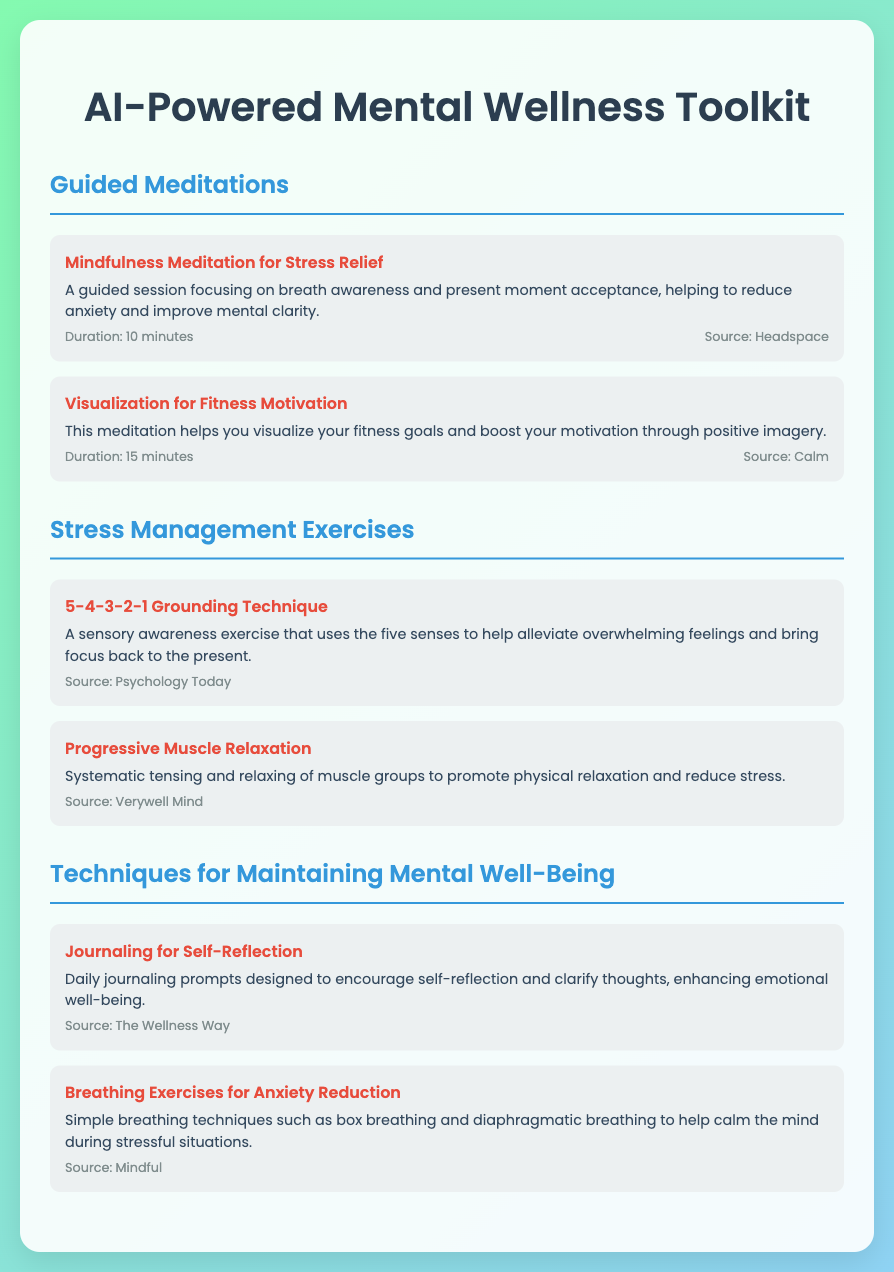What is the title of the toolkit? The title of the toolkit is prominently displayed at the top of the document.
Answer: AI-Powered Mental Wellness Toolkit How many guided meditations are listed? The document has two items under the guided meditations section.
Answer: 2 What is the duration of the Mindfulness Meditation for Stress Relief? The duration is mentioned in the item's meta details.
Answer: 10 minutes Which source is cited for the Progressive Muscle Relaxation technique? The source is detailed in the metadata of the item.
Answer: Verywell Mind What technique is used for anxiety reduction in breathing exercises? The document mentions specific methods used for anxiety reduction.
Answer: box breathing and diaphragmatic breathing What does the 5-4-3-2-1 grounding technique focus on? The description of the technique outlines its primary focus.
Answer: sensory awareness Which meditation helps visualize fitness goals? The title and description clearly state the focus of this meditation.
Answer: Visualization for Fitness Motivation 